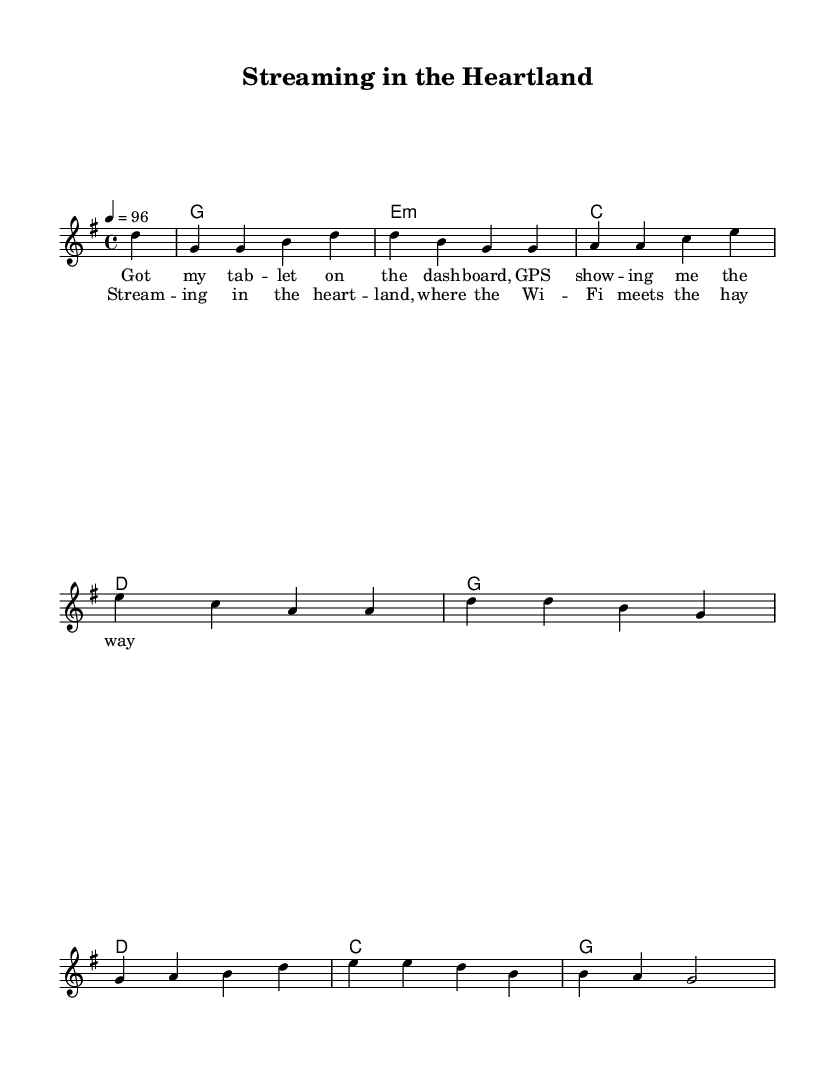What is the key signature of this music? The key signature is G major, which has one sharp (F#). This can be identified by looking at the key signature at the beginning of the sheet music.
Answer: G major What is the time signature of the piece? The time signature is 4/4, which means there are four beats per measure and the quarter note gets one beat. This is indicated at the beginning of the music next to the key signature.
Answer: 4/4 What is the tempo marking for this piece? The tempo marking is indicated as quarter note equals 96 beats per minute. This is noted at the beginning of the score, which provides the speed of the piece.
Answer: 96 How many lines are there in the melody? The melody consists of a single line that represents the primary vocal line of the song. The notation clearly shows a continuous flow of notes.
Answer: One line What is the first chord in the harmonies? The first chord in the harmonies is G major, which is represented as 'g1' in the chord section. The chord names are written in a format that denotes each chord in the sequence.
Answer: G major What is the theme of the lyrics in the verse? The theme of the lyrics in the verse reflects a modern country lifestyle, emphasizing the use of technology in day-to-day activities, illustrated by references to a tablet and GPS. This can be understood by reading the words set under the melody line.
Answer: Technology What is the setting described in the chorus? The setting described in the chorus contrasts the rural heartland with modern connectivity, referring to Wi-Fi in connection with traditional elements like hay. This contrast highlights the blend of contemporary and traditional imagery.
Answer: Heartland 